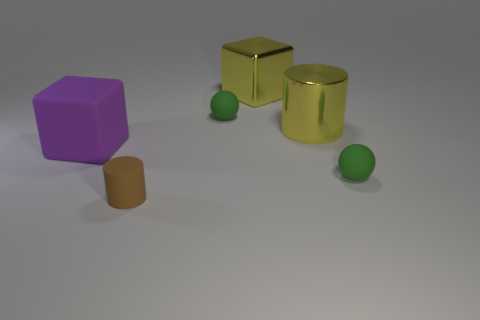Add 4 tiny spheres. How many objects exist? 10 Subtract all big cyan metallic things. Subtract all large purple rubber cubes. How many objects are left? 5 Add 2 yellow metal cylinders. How many yellow metal cylinders are left? 3 Add 6 big brown metallic blocks. How many big brown metallic blocks exist? 6 Subtract 1 purple blocks. How many objects are left? 5 Subtract all purple balls. Subtract all brown blocks. How many balls are left? 2 